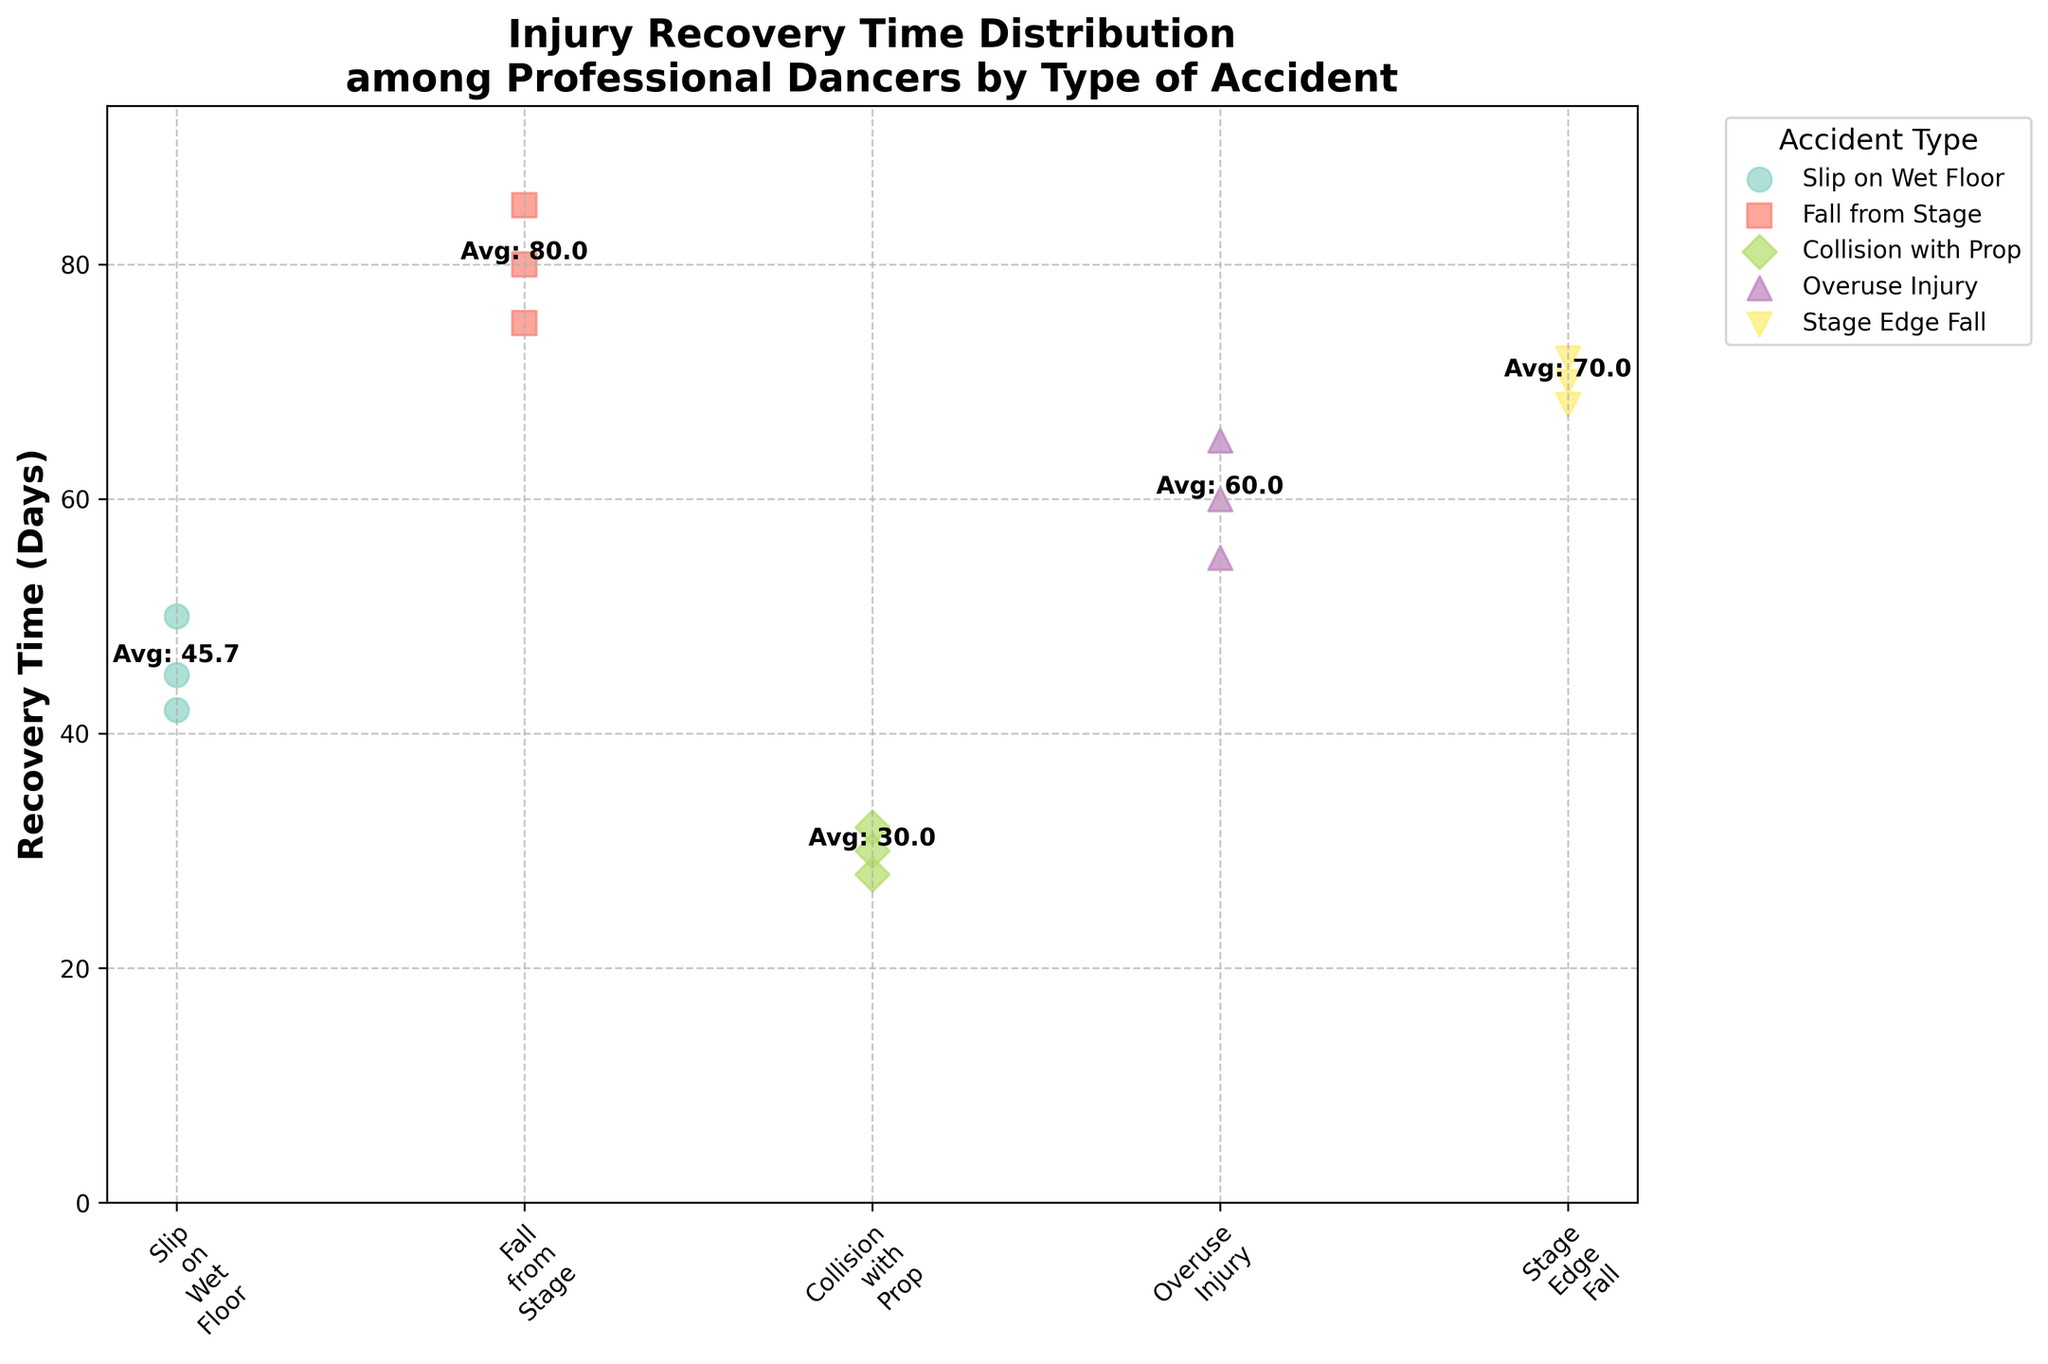What is the title of the plot? The title of the plot is found at the top and reads "Injury Recovery Time Distribution among Professional Dancers by Type of Accident".
Answer: Injury Recovery Time Distribution among Professional Dancers by Type of Accident How many accident types are displayed in the plot? There are five distinct accident types shown on the x-axis, which include Slip on Wet Floor, Fall from Stage, Collision with Prop, Overuse Injury, and Stage Edge Fall.
Answer: Five Which accident type has the highest average recovery time? The plot includes text annotations for average recovery times. The highest average recovery time is labeled on the Fall from Stage data points.
Answer: Fall from Stage What is the recovery time range for "Collision with Prop"? By looking at the y-axis values for the "Collision with Prop" data points, the lowest point is 28 days and the highest is 32 days.
Answer: 28-32 days What is the average recovery time for "Overuse Injury"? There is a text annotation directly above "Overuse Injury" data points that states the average recovery time is 60 days.
Answer: 60 days Which accident type has data points with the smallest recovery days? The lowest point on the y-axis corresponds to the "Collision with Prop" accident type which has a data point at 28 days.
Answer: Collision with Prop Compare the average recovery time between "Stage Edge Fall" and "Slip on Wet Floor". The plot annotations show that "Stage Edge Fall" has an average of approximately 70 days, while "Slip on Wet Floor" has an average closer to 45. Therefore, "Stage Edge Fall" has a higher average recovery time.
Answer: Stage Edge Fall How does the average recovery time of "Fall from Stage" compare to the average recovery time of "Overuse Injury"? From the annotations, "Fall from Stage" shows an average closer to 80 days, whereas "Overuse Injury" has an average of 60 days. Hence, "Fall from Stage" has a longer average recovery time.
Answer: Fall from Stage What type of accident has the most dispersed (spread out) recovery time data points? The scatter plot shows the data points spread out the most for "Fall from Stage" ranging from 75 to 85 days.
Answer: Fall from Stage Which type of accident has the closest recovery times among its data points? The data points for "Collision with Prop" are very close to each other, ranging from 28 to 32 days, indicating the least variation.
Answer: Collision with Prop 